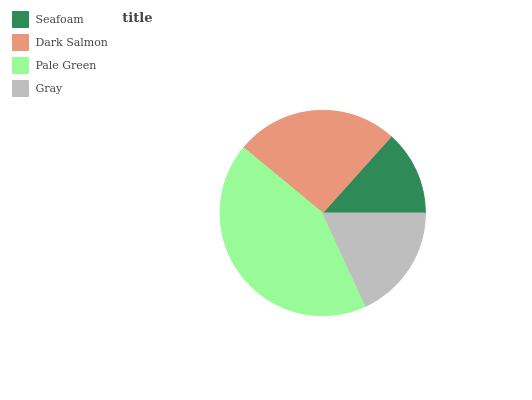Is Seafoam the minimum?
Answer yes or no. Yes. Is Pale Green the maximum?
Answer yes or no. Yes. Is Dark Salmon the minimum?
Answer yes or no. No. Is Dark Salmon the maximum?
Answer yes or no. No. Is Dark Salmon greater than Seafoam?
Answer yes or no. Yes. Is Seafoam less than Dark Salmon?
Answer yes or no. Yes. Is Seafoam greater than Dark Salmon?
Answer yes or no. No. Is Dark Salmon less than Seafoam?
Answer yes or no. No. Is Dark Salmon the high median?
Answer yes or no. Yes. Is Gray the low median?
Answer yes or no. Yes. Is Seafoam the high median?
Answer yes or no. No. Is Seafoam the low median?
Answer yes or no. No. 